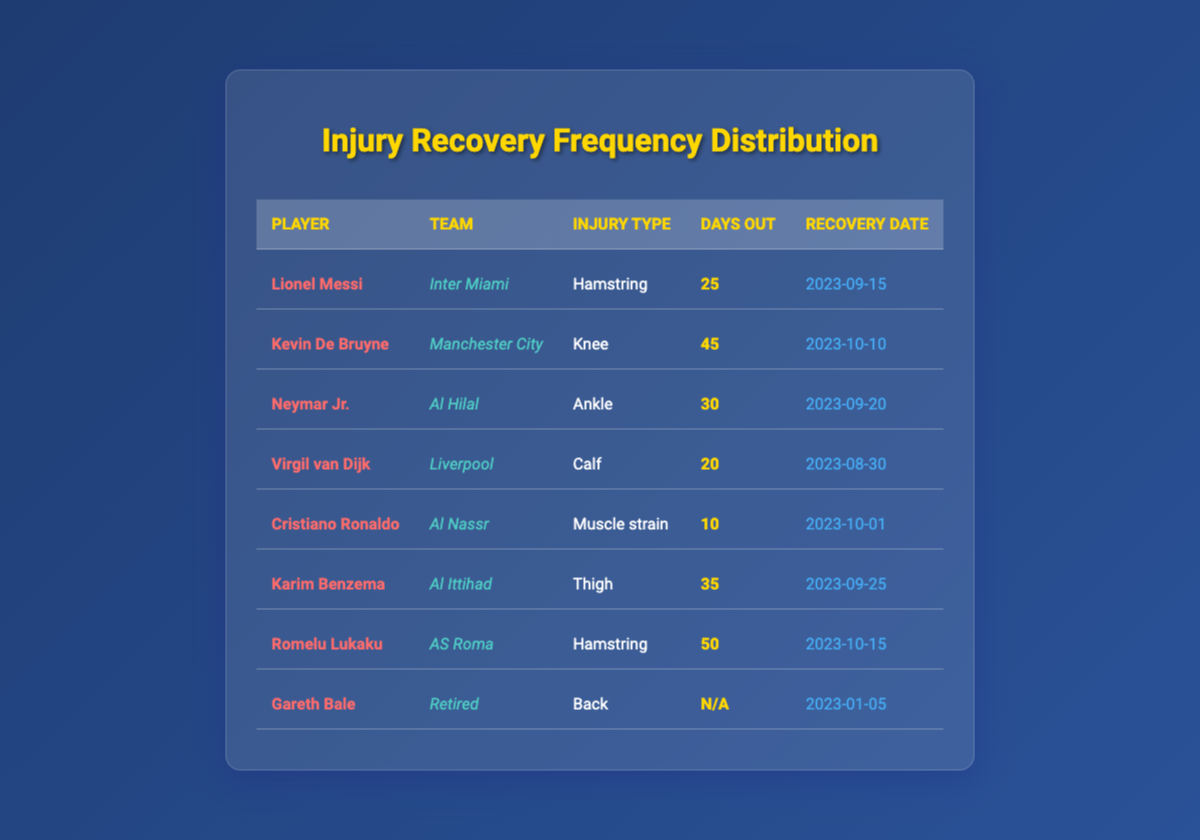What is the recovery date for Kevin De Bruyne? By looking at the table, I locate Kevin De Bruyne's row. In the "Recovery Date" column beside his name, the date is listed as "2023-10-10."
Answer: 2023-10-10 How many days was Romelu Lukaku out due to his injury? In the table, under Romelu Lukaku's entry in the "Days Out" column, it states he was out for 50 days.
Answer: 50 days Is Cristiano Ronaldo's injury classified as a hamstring injury? Checking the "Injury Type" column for Cristiano Ronaldo, it shows "Muscle strain," which indicates that his injury is not a hamstring injury.
Answer: No Which player had the longest recovery time, and how many days were they out? Examining the "Days Out" column for all players, Romelu Lukaku has the highest value at 50 days, indicating he had the longest recovery time.
Answer: Romelu Lukaku, 50 days What is the average number of days out for all players listed in the table? First, we sum the days out: 25 + 45 + 30 + 20 + 10 + 35 + 50 = 215. There are 7 players (excluding Gareth Bale whose days out are not applicable). Thus, the average is 215/7 = 30.71.
Answer: 30.71 Which team had the player with the shortest recovery time, and what was that time? Looking at the "Days Out" column, Cristiano Ronaldo came back in just 10 days. He plays for Al Nassr, so "Al Nassr" is the team with the shortest recovery time.
Answer: Al Nassr, 10 days Did any player have an injury that was considered back-related? According to the table, Gareth Bale's injury type is listed as "Back," confirming that one player had a back-related injury.
Answer: Yes How many players were out for more than 30 days? By reviewing the "Days Out" column, we identify players out for more than 30 days: Kevin De Bruyne (45), Karim Benzema (35), and Romelu Lukaku (50). Counting these, we find there are three players.
Answer: 3 